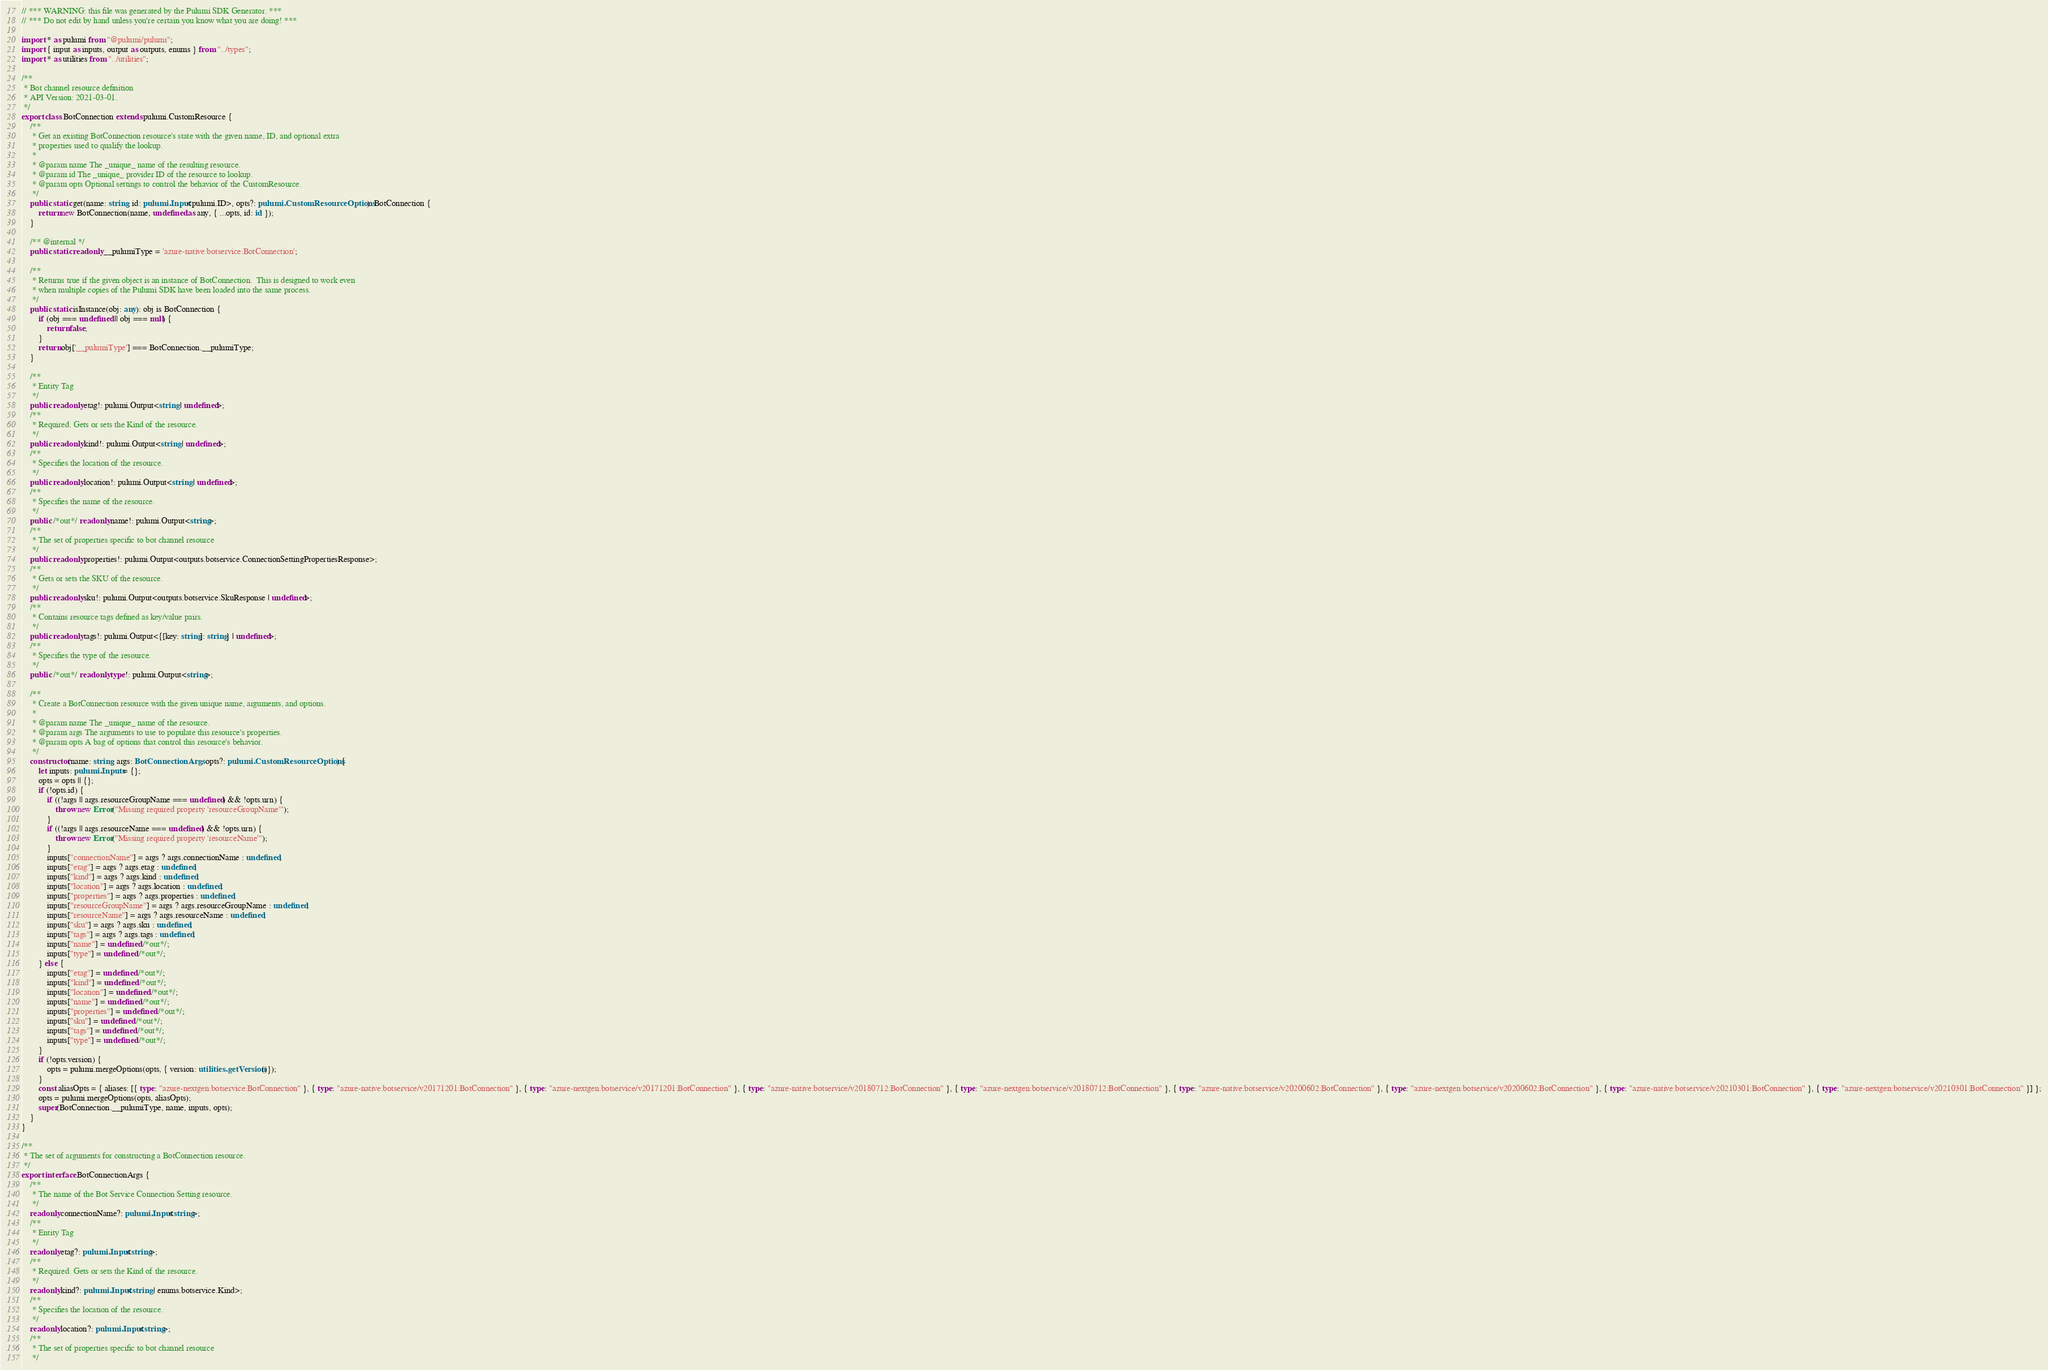Convert code to text. <code><loc_0><loc_0><loc_500><loc_500><_TypeScript_>// *** WARNING: this file was generated by the Pulumi SDK Generator. ***
// *** Do not edit by hand unless you're certain you know what you are doing! ***

import * as pulumi from "@pulumi/pulumi";
import { input as inputs, output as outputs, enums } from "../types";
import * as utilities from "../utilities";

/**
 * Bot channel resource definition
 * API Version: 2021-03-01.
 */
export class BotConnection extends pulumi.CustomResource {
    /**
     * Get an existing BotConnection resource's state with the given name, ID, and optional extra
     * properties used to qualify the lookup.
     *
     * @param name The _unique_ name of the resulting resource.
     * @param id The _unique_ provider ID of the resource to lookup.
     * @param opts Optional settings to control the behavior of the CustomResource.
     */
    public static get(name: string, id: pulumi.Input<pulumi.ID>, opts?: pulumi.CustomResourceOptions): BotConnection {
        return new BotConnection(name, undefined as any, { ...opts, id: id });
    }

    /** @internal */
    public static readonly __pulumiType = 'azure-native:botservice:BotConnection';

    /**
     * Returns true if the given object is an instance of BotConnection.  This is designed to work even
     * when multiple copies of the Pulumi SDK have been loaded into the same process.
     */
    public static isInstance(obj: any): obj is BotConnection {
        if (obj === undefined || obj === null) {
            return false;
        }
        return obj['__pulumiType'] === BotConnection.__pulumiType;
    }

    /**
     * Entity Tag
     */
    public readonly etag!: pulumi.Output<string | undefined>;
    /**
     * Required. Gets or sets the Kind of the resource.
     */
    public readonly kind!: pulumi.Output<string | undefined>;
    /**
     * Specifies the location of the resource.
     */
    public readonly location!: pulumi.Output<string | undefined>;
    /**
     * Specifies the name of the resource.
     */
    public /*out*/ readonly name!: pulumi.Output<string>;
    /**
     * The set of properties specific to bot channel resource
     */
    public readonly properties!: pulumi.Output<outputs.botservice.ConnectionSettingPropertiesResponse>;
    /**
     * Gets or sets the SKU of the resource.
     */
    public readonly sku!: pulumi.Output<outputs.botservice.SkuResponse | undefined>;
    /**
     * Contains resource tags defined as key/value pairs.
     */
    public readonly tags!: pulumi.Output<{[key: string]: string} | undefined>;
    /**
     * Specifies the type of the resource.
     */
    public /*out*/ readonly type!: pulumi.Output<string>;

    /**
     * Create a BotConnection resource with the given unique name, arguments, and options.
     *
     * @param name The _unique_ name of the resource.
     * @param args The arguments to use to populate this resource's properties.
     * @param opts A bag of options that control this resource's behavior.
     */
    constructor(name: string, args: BotConnectionArgs, opts?: pulumi.CustomResourceOptions) {
        let inputs: pulumi.Inputs = {};
        opts = opts || {};
        if (!opts.id) {
            if ((!args || args.resourceGroupName === undefined) && !opts.urn) {
                throw new Error("Missing required property 'resourceGroupName'");
            }
            if ((!args || args.resourceName === undefined) && !opts.urn) {
                throw new Error("Missing required property 'resourceName'");
            }
            inputs["connectionName"] = args ? args.connectionName : undefined;
            inputs["etag"] = args ? args.etag : undefined;
            inputs["kind"] = args ? args.kind : undefined;
            inputs["location"] = args ? args.location : undefined;
            inputs["properties"] = args ? args.properties : undefined;
            inputs["resourceGroupName"] = args ? args.resourceGroupName : undefined;
            inputs["resourceName"] = args ? args.resourceName : undefined;
            inputs["sku"] = args ? args.sku : undefined;
            inputs["tags"] = args ? args.tags : undefined;
            inputs["name"] = undefined /*out*/;
            inputs["type"] = undefined /*out*/;
        } else {
            inputs["etag"] = undefined /*out*/;
            inputs["kind"] = undefined /*out*/;
            inputs["location"] = undefined /*out*/;
            inputs["name"] = undefined /*out*/;
            inputs["properties"] = undefined /*out*/;
            inputs["sku"] = undefined /*out*/;
            inputs["tags"] = undefined /*out*/;
            inputs["type"] = undefined /*out*/;
        }
        if (!opts.version) {
            opts = pulumi.mergeOptions(opts, { version: utilities.getVersion()});
        }
        const aliasOpts = { aliases: [{ type: "azure-nextgen:botservice:BotConnection" }, { type: "azure-native:botservice/v20171201:BotConnection" }, { type: "azure-nextgen:botservice/v20171201:BotConnection" }, { type: "azure-native:botservice/v20180712:BotConnection" }, { type: "azure-nextgen:botservice/v20180712:BotConnection" }, { type: "azure-native:botservice/v20200602:BotConnection" }, { type: "azure-nextgen:botservice/v20200602:BotConnection" }, { type: "azure-native:botservice/v20210301:BotConnection" }, { type: "azure-nextgen:botservice/v20210301:BotConnection" }] };
        opts = pulumi.mergeOptions(opts, aliasOpts);
        super(BotConnection.__pulumiType, name, inputs, opts);
    }
}

/**
 * The set of arguments for constructing a BotConnection resource.
 */
export interface BotConnectionArgs {
    /**
     * The name of the Bot Service Connection Setting resource.
     */
    readonly connectionName?: pulumi.Input<string>;
    /**
     * Entity Tag
     */
    readonly etag?: pulumi.Input<string>;
    /**
     * Required. Gets or sets the Kind of the resource.
     */
    readonly kind?: pulumi.Input<string | enums.botservice.Kind>;
    /**
     * Specifies the location of the resource.
     */
    readonly location?: pulumi.Input<string>;
    /**
     * The set of properties specific to bot channel resource
     */</code> 